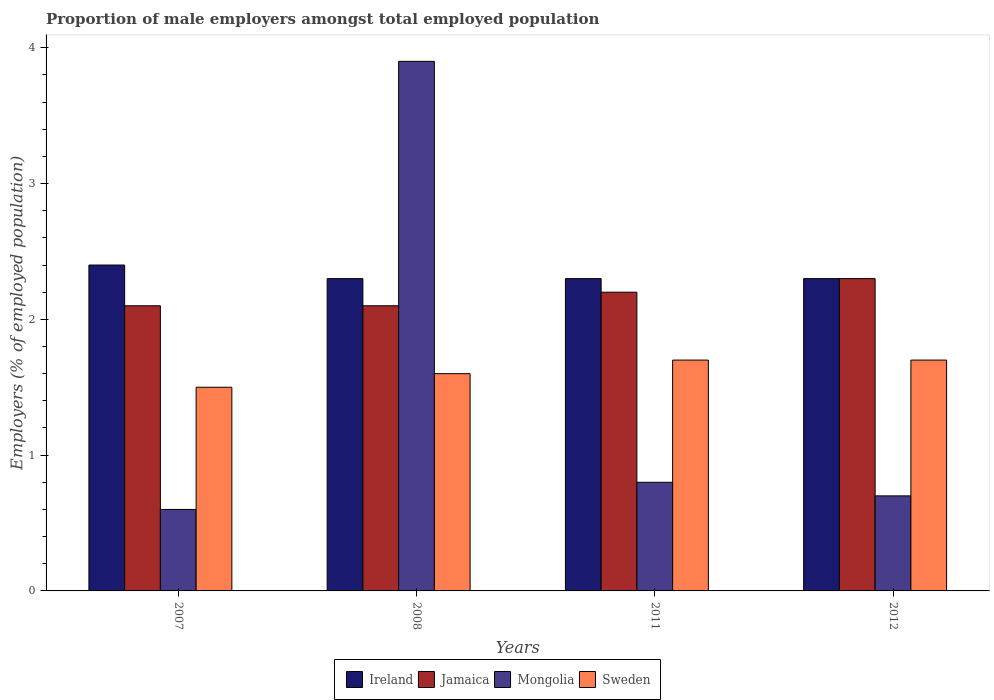How many different coloured bars are there?
Your response must be concise. 4. Are the number of bars on each tick of the X-axis equal?
Keep it short and to the point. Yes. What is the label of the 1st group of bars from the left?
Your response must be concise. 2007. In how many cases, is the number of bars for a given year not equal to the number of legend labels?
Your answer should be very brief. 0. What is the proportion of male employers in Ireland in 2008?
Offer a very short reply. 2.3. Across all years, what is the maximum proportion of male employers in Sweden?
Offer a very short reply. 1.7. Across all years, what is the minimum proportion of male employers in Sweden?
Provide a succinct answer. 1.5. What is the total proportion of male employers in Mongolia in the graph?
Your answer should be compact. 6. What is the difference between the proportion of male employers in Jamaica in 2007 and that in 2008?
Ensure brevity in your answer.  0. What is the difference between the proportion of male employers in Mongolia in 2007 and the proportion of male employers in Ireland in 2011?
Make the answer very short. -1.7. What is the average proportion of male employers in Jamaica per year?
Give a very brief answer. 2.17. In the year 2007, what is the difference between the proportion of male employers in Mongolia and proportion of male employers in Ireland?
Your answer should be compact. -1.8. In how many years, is the proportion of male employers in Sweden greater than 2.6 %?
Offer a very short reply. 0. What is the ratio of the proportion of male employers in Ireland in 2007 to that in 2011?
Offer a very short reply. 1.04. What is the difference between the highest and the second highest proportion of male employers in Mongolia?
Provide a succinct answer. 3.1. What is the difference between the highest and the lowest proportion of male employers in Jamaica?
Give a very brief answer. 0.2. Is it the case that in every year, the sum of the proportion of male employers in Sweden and proportion of male employers in Jamaica is greater than the sum of proportion of male employers in Mongolia and proportion of male employers in Ireland?
Provide a succinct answer. No. What does the 1st bar from the left in 2007 represents?
Offer a terse response. Ireland. What does the 4th bar from the right in 2007 represents?
Your answer should be very brief. Ireland. Are all the bars in the graph horizontal?
Ensure brevity in your answer.  No. What is the difference between two consecutive major ticks on the Y-axis?
Provide a short and direct response. 1. Are the values on the major ticks of Y-axis written in scientific E-notation?
Your answer should be compact. No. Does the graph contain grids?
Your response must be concise. No. What is the title of the graph?
Your answer should be compact. Proportion of male employers amongst total employed population. What is the label or title of the X-axis?
Offer a very short reply. Years. What is the label or title of the Y-axis?
Keep it short and to the point. Employers (% of employed population). What is the Employers (% of employed population) of Ireland in 2007?
Your response must be concise. 2.4. What is the Employers (% of employed population) in Jamaica in 2007?
Offer a very short reply. 2.1. What is the Employers (% of employed population) of Mongolia in 2007?
Offer a very short reply. 0.6. What is the Employers (% of employed population) of Sweden in 2007?
Your answer should be very brief. 1.5. What is the Employers (% of employed population) in Ireland in 2008?
Provide a succinct answer. 2.3. What is the Employers (% of employed population) of Jamaica in 2008?
Give a very brief answer. 2.1. What is the Employers (% of employed population) of Mongolia in 2008?
Make the answer very short. 3.9. What is the Employers (% of employed population) in Sweden in 2008?
Your answer should be compact. 1.6. What is the Employers (% of employed population) in Ireland in 2011?
Give a very brief answer. 2.3. What is the Employers (% of employed population) of Jamaica in 2011?
Provide a short and direct response. 2.2. What is the Employers (% of employed population) of Mongolia in 2011?
Your response must be concise. 0.8. What is the Employers (% of employed population) of Sweden in 2011?
Your response must be concise. 1.7. What is the Employers (% of employed population) of Ireland in 2012?
Your answer should be compact. 2.3. What is the Employers (% of employed population) in Jamaica in 2012?
Offer a very short reply. 2.3. What is the Employers (% of employed population) in Mongolia in 2012?
Give a very brief answer. 0.7. What is the Employers (% of employed population) in Sweden in 2012?
Offer a terse response. 1.7. Across all years, what is the maximum Employers (% of employed population) of Ireland?
Your response must be concise. 2.4. Across all years, what is the maximum Employers (% of employed population) in Jamaica?
Provide a short and direct response. 2.3. Across all years, what is the maximum Employers (% of employed population) in Mongolia?
Offer a terse response. 3.9. Across all years, what is the maximum Employers (% of employed population) of Sweden?
Your response must be concise. 1.7. Across all years, what is the minimum Employers (% of employed population) in Ireland?
Give a very brief answer. 2.3. Across all years, what is the minimum Employers (% of employed population) of Jamaica?
Provide a short and direct response. 2.1. Across all years, what is the minimum Employers (% of employed population) of Mongolia?
Ensure brevity in your answer.  0.6. Across all years, what is the minimum Employers (% of employed population) in Sweden?
Offer a very short reply. 1.5. What is the total Employers (% of employed population) of Ireland in the graph?
Give a very brief answer. 9.3. What is the total Employers (% of employed population) in Jamaica in the graph?
Ensure brevity in your answer.  8.7. What is the total Employers (% of employed population) of Mongolia in the graph?
Provide a succinct answer. 6. What is the total Employers (% of employed population) of Sweden in the graph?
Give a very brief answer. 6.5. What is the difference between the Employers (% of employed population) of Jamaica in 2007 and that in 2008?
Make the answer very short. 0. What is the difference between the Employers (% of employed population) of Mongolia in 2007 and that in 2008?
Provide a short and direct response. -3.3. What is the difference between the Employers (% of employed population) in Jamaica in 2007 and that in 2011?
Ensure brevity in your answer.  -0.1. What is the difference between the Employers (% of employed population) in Sweden in 2007 and that in 2011?
Keep it short and to the point. -0.2. What is the difference between the Employers (% of employed population) in Ireland in 2008 and that in 2011?
Your response must be concise. 0. What is the difference between the Employers (% of employed population) of Jamaica in 2008 and that in 2011?
Ensure brevity in your answer.  -0.1. What is the difference between the Employers (% of employed population) of Sweden in 2008 and that in 2011?
Offer a terse response. -0.1. What is the difference between the Employers (% of employed population) of Jamaica in 2008 and that in 2012?
Make the answer very short. -0.2. What is the difference between the Employers (% of employed population) in Mongolia in 2008 and that in 2012?
Offer a terse response. 3.2. What is the difference between the Employers (% of employed population) of Sweden in 2008 and that in 2012?
Offer a terse response. -0.1. What is the difference between the Employers (% of employed population) in Ireland in 2011 and that in 2012?
Provide a succinct answer. 0. What is the difference between the Employers (% of employed population) of Jamaica in 2011 and that in 2012?
Your response must be concise. -0.1. What is the difference between the Employers (% of employed population) of Mongolia in 2011 and that in 2012?
Ensure brevity in your answer.  0.1. What is the difference between the Employers (% of employed population) of Ireland in 2007 and the Employers (% of employed population) of Jamaica in 2008?
Offer a very short reply. 0.3. What is the difference between the Employers (% of employed population) in Ireland in 2007 and the Employers (% of employed population) in Sweden in 2008?
Your answer should be compact. 0.8. What is the difference between the Employers (% of employed population) of Jamaica in 2007 and the Employers (% of employed population) of Mongolia in 2008?
Your response must be concise. -1.8. What is the difference between the Employers (% of employed population) of Jamaica in 2007 and the Employers (% of employed population) of Sweden in 2008?
Keep it short and to the point. 0.5. What is the difference between the Employers (% of employed population) of Mongolia in 2007 and the Employers (% of employed population) of Sweden in 2008?
Your answer should be very brief. -1. What is the difference between the Employers (% of employed population) in Ireland in 2007 and the Employers (% of employed population) in Jamaica in 2011?
Give a very brief answer. 0.2. What is the difference between the Employers (% of employed population) of Ireland in 2007 and the Employers (% of employed population) of Mongolia in 2011?
Your answer should be compact. 1.6. What is the difference between the Employers (% of employed population) of Jamaica in 2007 and the Employers (% of employed population) of Mongolia in 2011?
Give a very brief answer. 1.3. What is the difference between the Employers (% of employed population) of Jamaica in 2007 and the Employers (% of employed population) of Sweden in 2011?
Give a very brief answer. 0.4. What is the difference between the Employers (% of employed population) in Mongolia in 2007 and the Employers (% of employed population) in Sweden in 2011?
Your answer should be compact. -1.1. What is the difference between the Employers (% of employed population) in Ireland in 2007 and the Employers (% of employed population) in Mongolia in 2012?
Ensure brevity in your answer.  1.7. What is the difference between the Employers (% of employed population) in Mongolia in 2007 and the Employers (% of employed population) in Sweden in 2012?
Offer a very short reply. -1.1. What is the difference between the Employers (% of employed population) of Ireland in 2008 and the Employers (% of employed population) of Sweden in 2011?
Give a very brief answer. 0.6. What is the difference between the Employers (% of employed population) in Jamaica in 2008 and the Employers (% of employed population) in Mongolia in 2011?
Offer a very short reply. 1.3. What is the difference between the Employers (% of employed population) of Ireland in 2008 and the Employers (% of employed population) of Sweden in 2012?
Offer a very short reply. 0.6. What is the difference between the Employers (% of employed population) in Jamaica in 2008 and the Employers (% of employed population) in Sweden in 2012?
Provide a short and direct response. 0.4. What is the difference between the Employers (% of employed population) of Mongolia in 2008 and the Employers (% of employed population) of Sweden in 2012?
Offer a very short reply. 2.2. What is the difference between the Employers (% of employed population) in Ireland in 2011 and the Employers (% of employed population) in Mongolia in 2012?
Give a very brief answer. 1.6. What is the difference between the Employers (% of employed population) in Mongolia in 2011 and the Employers (% of employed population) in Sweden in 2012?
Your answer should be very brief. -0.9. What is the average Employers (% of employed population) of Ireland per year?
Offer a very short reply. 2.33. What is the average Employers (% of employed population) of Jamaica per year?
Provide a succinct answer. 2.17. What is the average Employers (% of employed population) in Sweden per year?
Your response must be concise. 1.62. In the year 2007, what is the difference between the Employers (% of employed population) in Ireland and Employers (% of employed population) in Jamaica?
Offer a terse response. 0.3. In the year 2007, what is the difference between the Employers (% of employed population) in Ireland and Employers (% of employed population) in Sweden?
Provide a short and direct response. 0.9. In the year 2008, what is the difference between the Employers (% of employed population) in Ireland and Employers (% of employed population) in Jamaica?
Offer a terse response. 0.2. In the year 2008, what is the difference between the Employers (% of employed population) of Ireland and Employers (% of employed population) of Sweden?
Your response must be concise. 0.7. In the year 2008, what is the difference between the Employers (% of employed population) of Jamaica and Employers (% of employed population) of Mongolia?
Ensure brevity in your answer.  -1.8. In the year 2008, what is the difference between the Employers (% of employed population) in Mongolia and Employers (% of employed population) in Sweden?
Provide a short and direct response. 2.3. In the year 2011, what is the difference between the Employers (% of employed population) of Mongolia and Employers (% of employed population) of Sweden?
Ensure brevity in your answer.  -0.9. In the year 2012, what is the difference between the Employers (% of employed population) of Jamaica and Employers (% of employed population) of Mongolia?
Provide a succinct answer. 1.6. In the year 2012, what is the difference between the Employers (% of employed population) in Mongolia and Employers (% of employed population) in Sweden?
Provide a succinct answer. -1. What is the ratio of the Employers (% of employed population) in Ireland in 2007 to that in 2008?
Ensure brevity in your answer.  1.04. What is the ratio of the Employers (% of employed population) in Jamaica in 2007 to that in 2008?
Give a very brief answer. 1. What is the ratio of the Employers (% of employed population) of Mongolia in 2007 to that in 2008?
Your response must be concise. 0.15. What is the ratio of the Employers (% of employed population) of Ireland in 2007 to that in 2011?
Keep it short and to the point. 1.04. What is the ratio of the Employers (% of employed population) in Jamaica in 2007 to that in 2011?
Offer a terse response. 0.95. What is the ratio of the Employers (% of employed population) of Sweden in 2007 to that in 2011?
Offer a terse response. 0.88. What is the ratio of the Employers (% of employed population) of Ireland in 2007 to that in 2012?
Provide a short and direct response. 1.04. What is the ratio of the Employers (% of employed population) in Sweden in 2007 to that in 2012?
Give a very brief answer. 0.88. What is the ratio of the Employers (% of employed population) in Jamaica in 2008 to that in 2011?
Offer a terse response. 0.95. What is the ratio of the Employers (% of employed population) in Mongolia in 2008 to that in 2011?
Make the answer very short. 4.88. What is the ratio of the Employers (% of employed population) of Sweden in 2008 to that in 2011?
Offer a terse response. 0.94. What is the ratio of the Employers (% of employed population) in Mongolia in 2008 to that in 2012?
Provide a succinct answer. 5.57. What is the ratio of the Employers (% of employed population) in Jamaica in 2011 to that in 2012?
Offer a terse response. 0.96. What is the ratio of the Employers (% of employed population) in Mongolia in 2011 to that in 2012?
Ensure brevity in your answer.  1.14. What is the ratio of the Employers (% of employed population) of Sweden in 2011 to that in 2012?
Make the answer very short. 1. What is the difference between the highest and the lowest Employers (% of employed population) in Jamaica?
Offer a very short reply. 0.2. What is the difference between the highest and the lowest Employers (% of employed population) of Mongolia?
Offer a terse response. 3.3. What is the difference between the highest and the lowest Employers (% of employed population) of Sweden?
Your answer should be very brief. 0.2. 